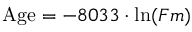<formula> <loc_0><loc_0><loc_500><loc_500>{ A g e } = - 8 0 3 3 \cdot \ln ( F m )</formula> 